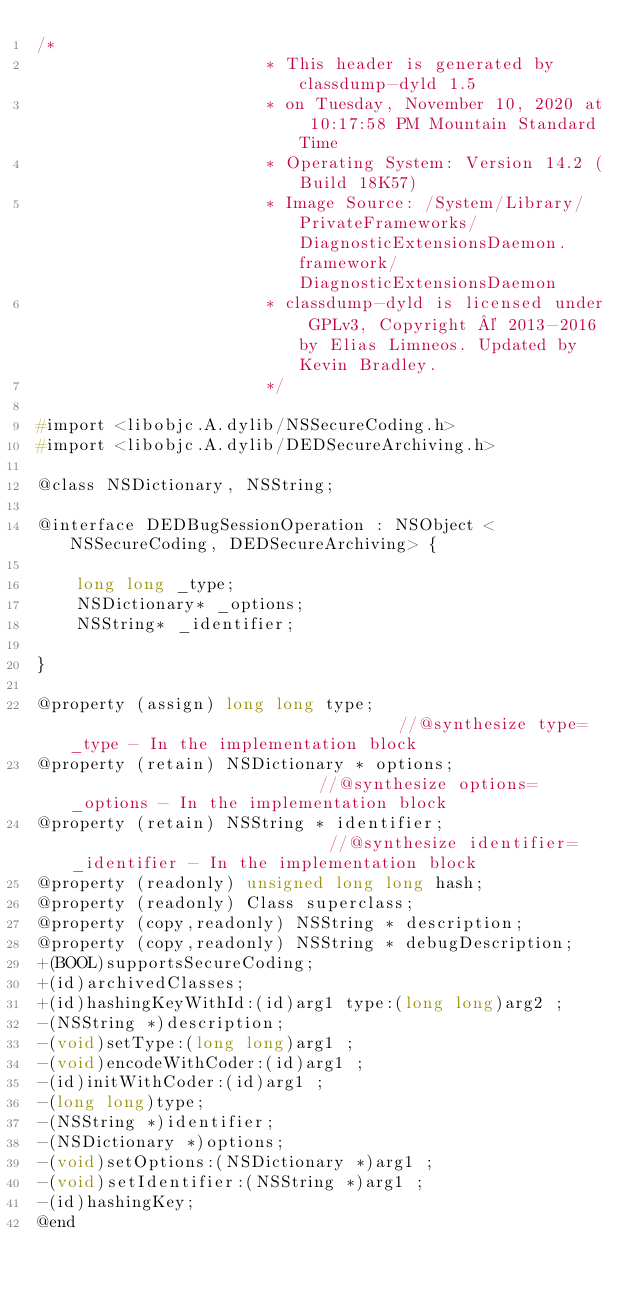Convert code to text. <code><loc_0><loc_0><loc_500><loc_500><_C_>/*
                       * This header is generated by classdump-dyld 1.5
                       * on Tuesday, November 10, 2020 at 10:17:58 PM Mountain Standard Time
                       * Operating System: Version 14.2 (Build 18K57)
                       * Image Source: /System/Library/PrivateFrameworks/DiagnosticExtensionsDaemon.framework/DiagnosticExtensionsDaemon
                       * classdump-dyld is licensed under GPLv3, Copyright © 2013-2016 by Elias Limneos. Updated by Kevin Bradley.
                       */

#import <libobjc.A.dylib/NSSecureCoding.h>
#import <libobjc.A.dylib/DEDSecureArchiving.h>

@class NSDictionary, NSString;

@interface DEDBugSessionOperation : NSObject <NSSecureCoding, DEDSecureArchiving> {

	long long _type;
	NSDictionary* _options;
	NSString* _identifier;

}

@property (assign) long long type;                                  //@synthesize type=_type - In the implementation block
@property (retain) NSDictionary * options;                          //@synthesize options=_options - In the implementation block
@property (retain) NSString * identifier;                           //@synthesize identifier=_identifier - In the implementation block
@property (readonly) unsigned long long hash; 
@property (readonly) Class superclass; 
@property (copy,readonly) NSString * description; 
@property (copy,readonly) NSString * debugDescription; 
+(BOOL)supportsSecureCoding;
+(id)archivedClasses;
+(id)hashingKeyWithId:(id)arg1 type:(long long)arg2 ;
-(NSString *)description;
-(void)setType:(long long)arg1 ;
-(void)encodeWithCoder:(id)arg1 ;
-(id)initWithCoder:(id)arg1 ;
-(long long)type;
-(NSString *)identifier;
-(NSDictionary *)options;
-(void)setOptions:(NSDictionary *)arg1 ;
-(void)setIdentifier:(NSString *)arg1 ;
-(id)hashingKey;
@end

</code> 